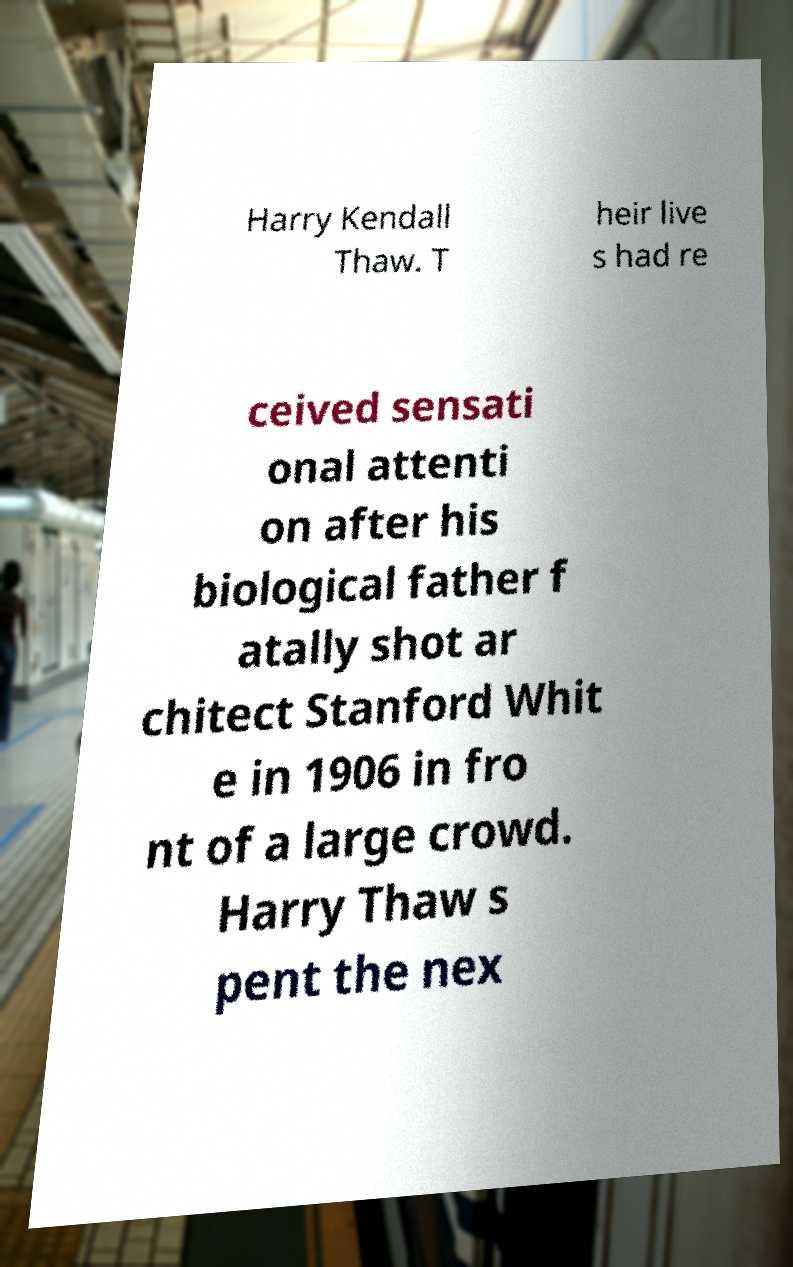Please identify and transcribe the text found in this image. Harry Kendall Thaw. T heir live s had re ceived sensati onal attenti on after his biological father f atally shot ar chitect Stanford Whit e in 1906 in fro nt of a large crowd. Harry Thaw s pent the nex 